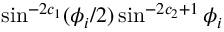Convert formula to latex. <formula><loc_0><loc_0><loc_500><loc_500>\sin ^ { - 2 c _ { 1 } } ( \phi _ { i } / 2 ) \sin ^ { - 2 c _ { 2 } + 1 } \phi _ { i }</formula> 